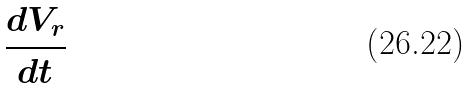<formula> <loc_0><loc_0><loc_500><loc_500>\frac { d V _ { r } } { d t }</formula> 